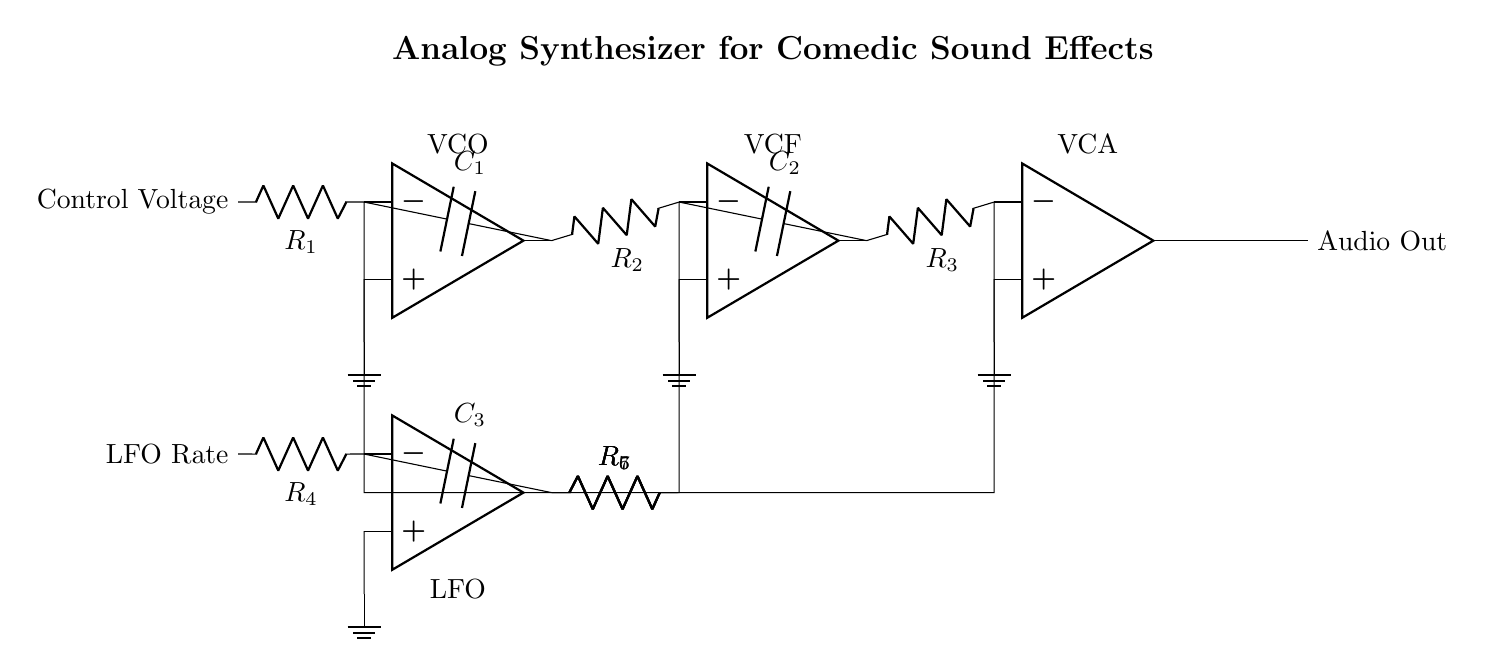What are the main components in this circuit? The main components include a Voltage Controlled Oscillator (VCO), Voltage Controlled Filter (VCF), Voltage Controlled Amplifier (VCA), and Low Frequency Oscillator (LFO). Each component is marked in the circuit and plays a critical role in synthesizing sound.
Answer: VCO, VCF, VCA, LFO What does LFO control in this circuit? The LFO controls the modulation rates applied to the VCO, VCF, and VCA through resistors. The control voltage connection allows the LFO's frequency to influence the other components, effectively shaping the output sound.
Answer: Modulation rates How many resistors are present in the circuit? There are seven resistors depicted in the circuit diagram. Each resistor serves a distinct purpose in controlling signals within different sections of the synthesizer.
Answer: Seven What is the purpose of the VCA in the circuit? The VCA's role is to control the amplitude of the audio signal coming from the VCF. It allows adjustments to the loudness of the output sound, making it possible to create dynamics in the synthesized audio.
Answer: Amplitude control Which component directly receives the output from the VCO? The VCF directly receives the output from the VCO. This connection allows the filter to process the sound generated by the oscillator before amplification.
Answer: VCF What type of synthesizer is depicted in the circuit? The circuit represents an analog synthesizer which utilizes various analog components to generate and manipulate sound waves, suitable for creating distinct sound effects.
Answer: Analog synthesizer 